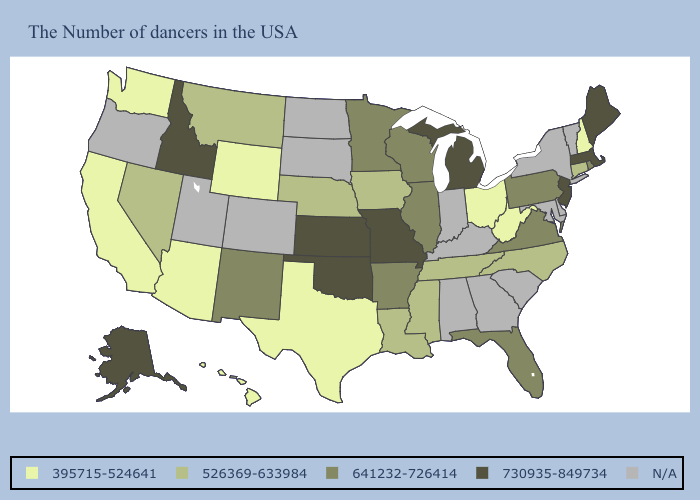What is the lowest value in states that border Utah?
Write a very short answer. 395715-524641. Name the states that have a value in the range N/A?
Keep it brief. Vermont, New York, Delaware, Maryland, South Carolina, Georgia, Kentucky, Indiana, Alabama, South Dakota, North Dakota, Colorado, Utah, Oregon. Name the states that have a value in the range 395715-524641?
Concise answer only. New Hampshire, West Virginia, Ohio, Texas, Wyoming, Arizona, California, Washington, Hawaii. Name the states that have a value in the range 526369-633984?
Give a very brief answer. Connecticut, North Carolina, Tennessee, Mississippi, Louisiana, Iowa, Nebraska, Montana, Nevada. What is the value of Connecticut?
Quick response, please. 526369-633984. Name the states that have a value in the range N/A?
Give a very brief answer. Vermont, New York, Delaware, Maryland, South Carolina, Georgia, Kentucky, Indiana, Alabama, South Dakota, North Dakota, Colorado, Utah, Oregon. Name the states that have a value in the range 526369-633984?
Short answer required. Connecticut, North Carolina, Tennessee, Mississippi, Louisiana, Iowa, Nebraska, Montana, Nevada. Name the states that have a value in the range 395715-524641?
Keep it brief. New Hampshire, West Virginia, Ohio, Texas, Wyoming, Arizona, California, Washington, Hawaii. What is the value of Wisconsin?
Quick response, please. 641232-726414. Which states have the lowest value in the MidWest?
Write a very short answer. Ohio. Name the states that have a value in the range N/A?
Keep it brief. Vermont, New York, Delaware, Maryland, South Carolina, Georgia, Kentucky, Indiana, Alabama, South Dakota, North Dakota, Colorado, Utah, Oregon. What is the value of Missouri?
Keep it brief. 730935-849734. Name the states that have a value in the range 395715-524641?
Be succinct. New Hampshire, West Virginia, Ohio, Texas, Wyoming, Arizona, California, Washington, Hawaii. Name the states that have a value in the range 641232-726414?
Give a very brief answer. Rhode Island, Pennsylvania, Virginia, Florida, Wisconsin, Illinois, Arkansas, Minnesota, New Mexico. 